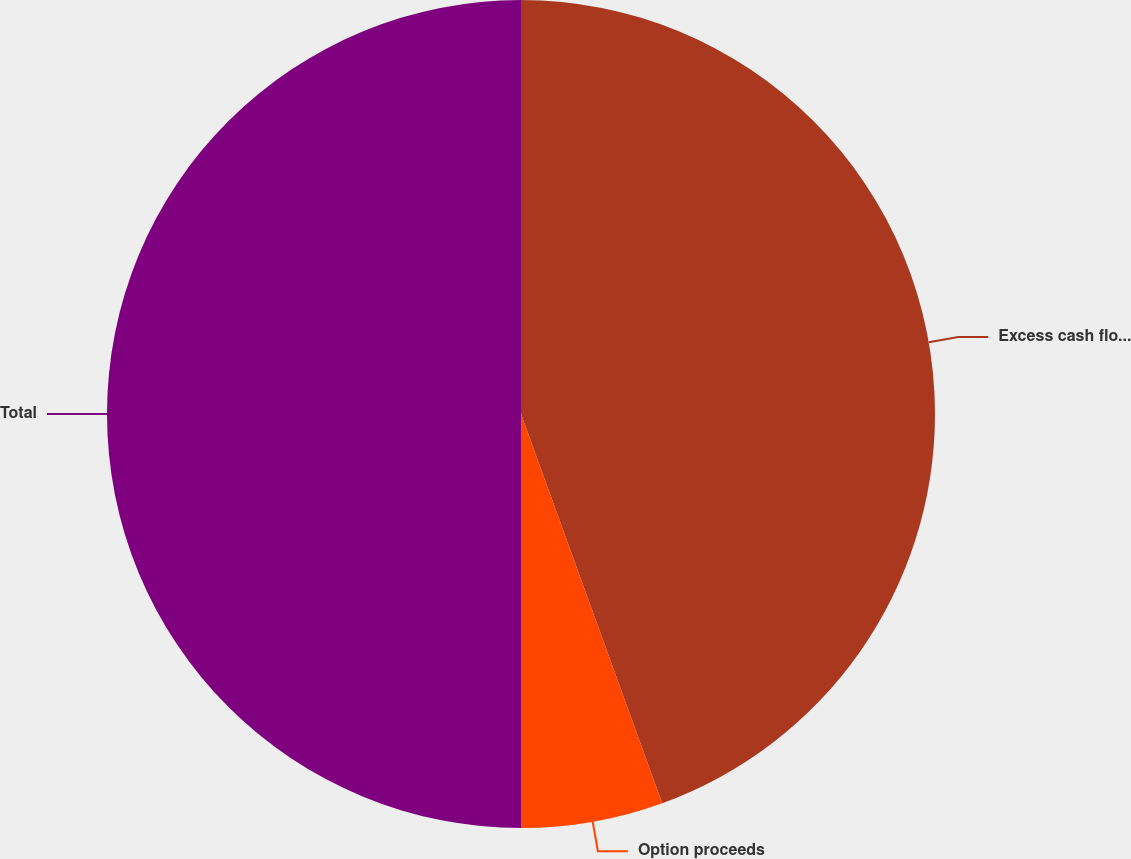Convert chart to OTSL. <chart><loc_0><loc_0><loc_500><loc_500><pie_chart><fcel>Excess cash flow and<fcel>Option proceeds<fcel>Total<nl><fcel>44.46%<fcel>5.54%<fcel>50.0%<nl></chart> 